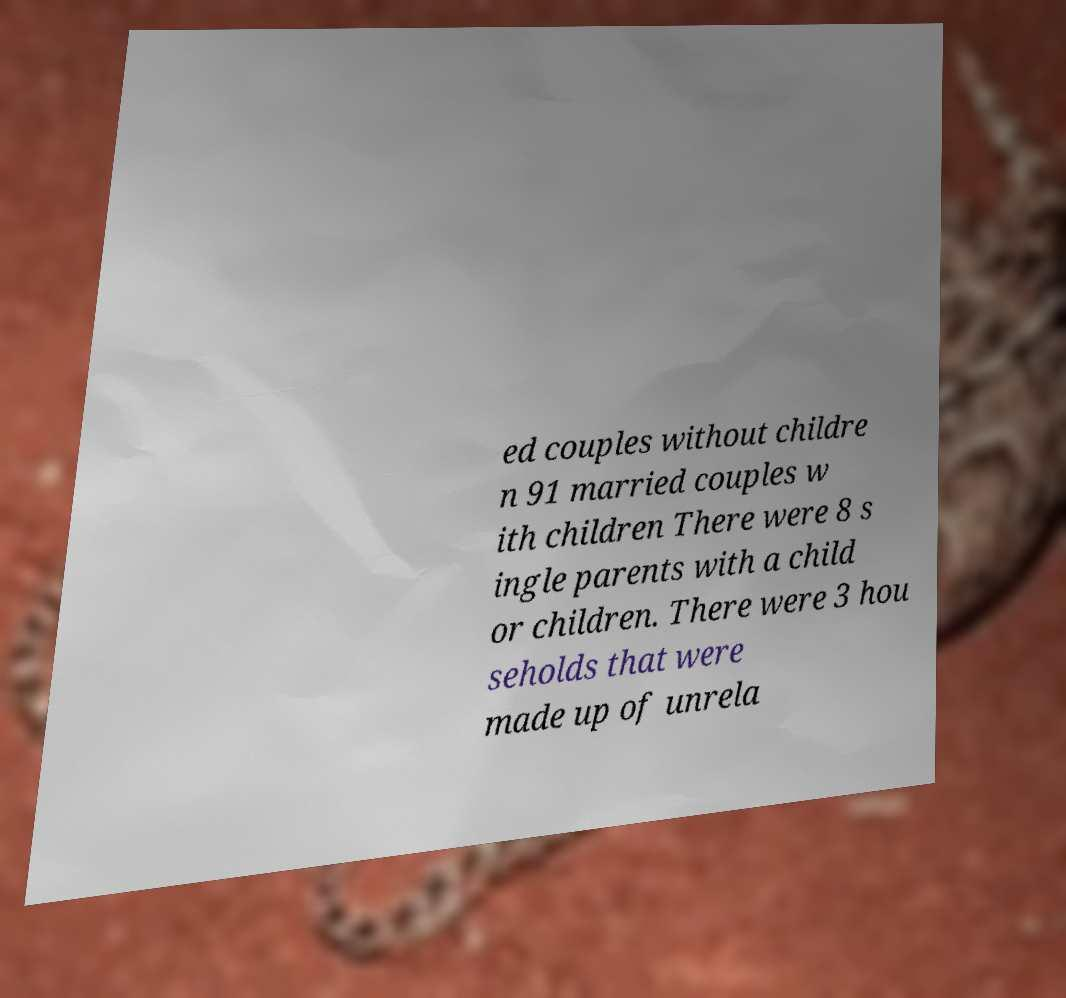I need the written content from this picture converted into text. Can you do that? ed couples without childre n 91 married couples w ith children There were 8 s ingle parents with a child or children. There were 3 hou seholds that were made up of unrela 